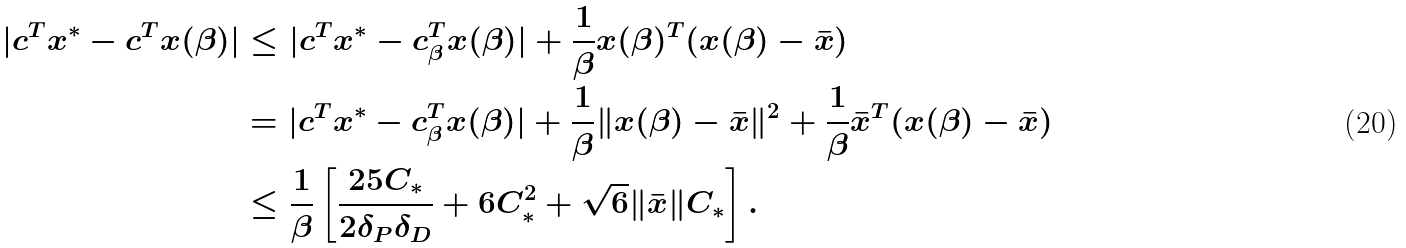Convert formula to latex. <formula><loc_0><loc_0><loc_500><loc_500>| c ^ { T } x ^ { * } - c ^ { T } x ( \beta ) | & \leq | c ^ { T } x ^ { * } - c _ { \beta } ^ { T } x ( \beta ) | + \frac { 1 } { \beta } x ( \beta ) ^ { T } ( x ( \beta ) - \bar { x } ) \\ & = | c ^ { T } x ^ { * } - c _ { \beta } ^ { T } x ( \beta ) | + \frac { 1 } { \beta } \| x ( \beta ) - \bar { x } \| ^ { 2 } + \frac { 1 } { \beta } \bar { x } ^ { T } ( x ( \beta ) - \bar { x } ) \\ & \leq \frac { 1 } { \beta } \left [ \frac { 2 5 C _ { * } } { 2 \delta _ { P } \delta _ { D } } + 6 C _ { * } ^ { 2 } + \sqrt { 6 } \| \bar { x } \| C _ { * } \right ] .</formula> 